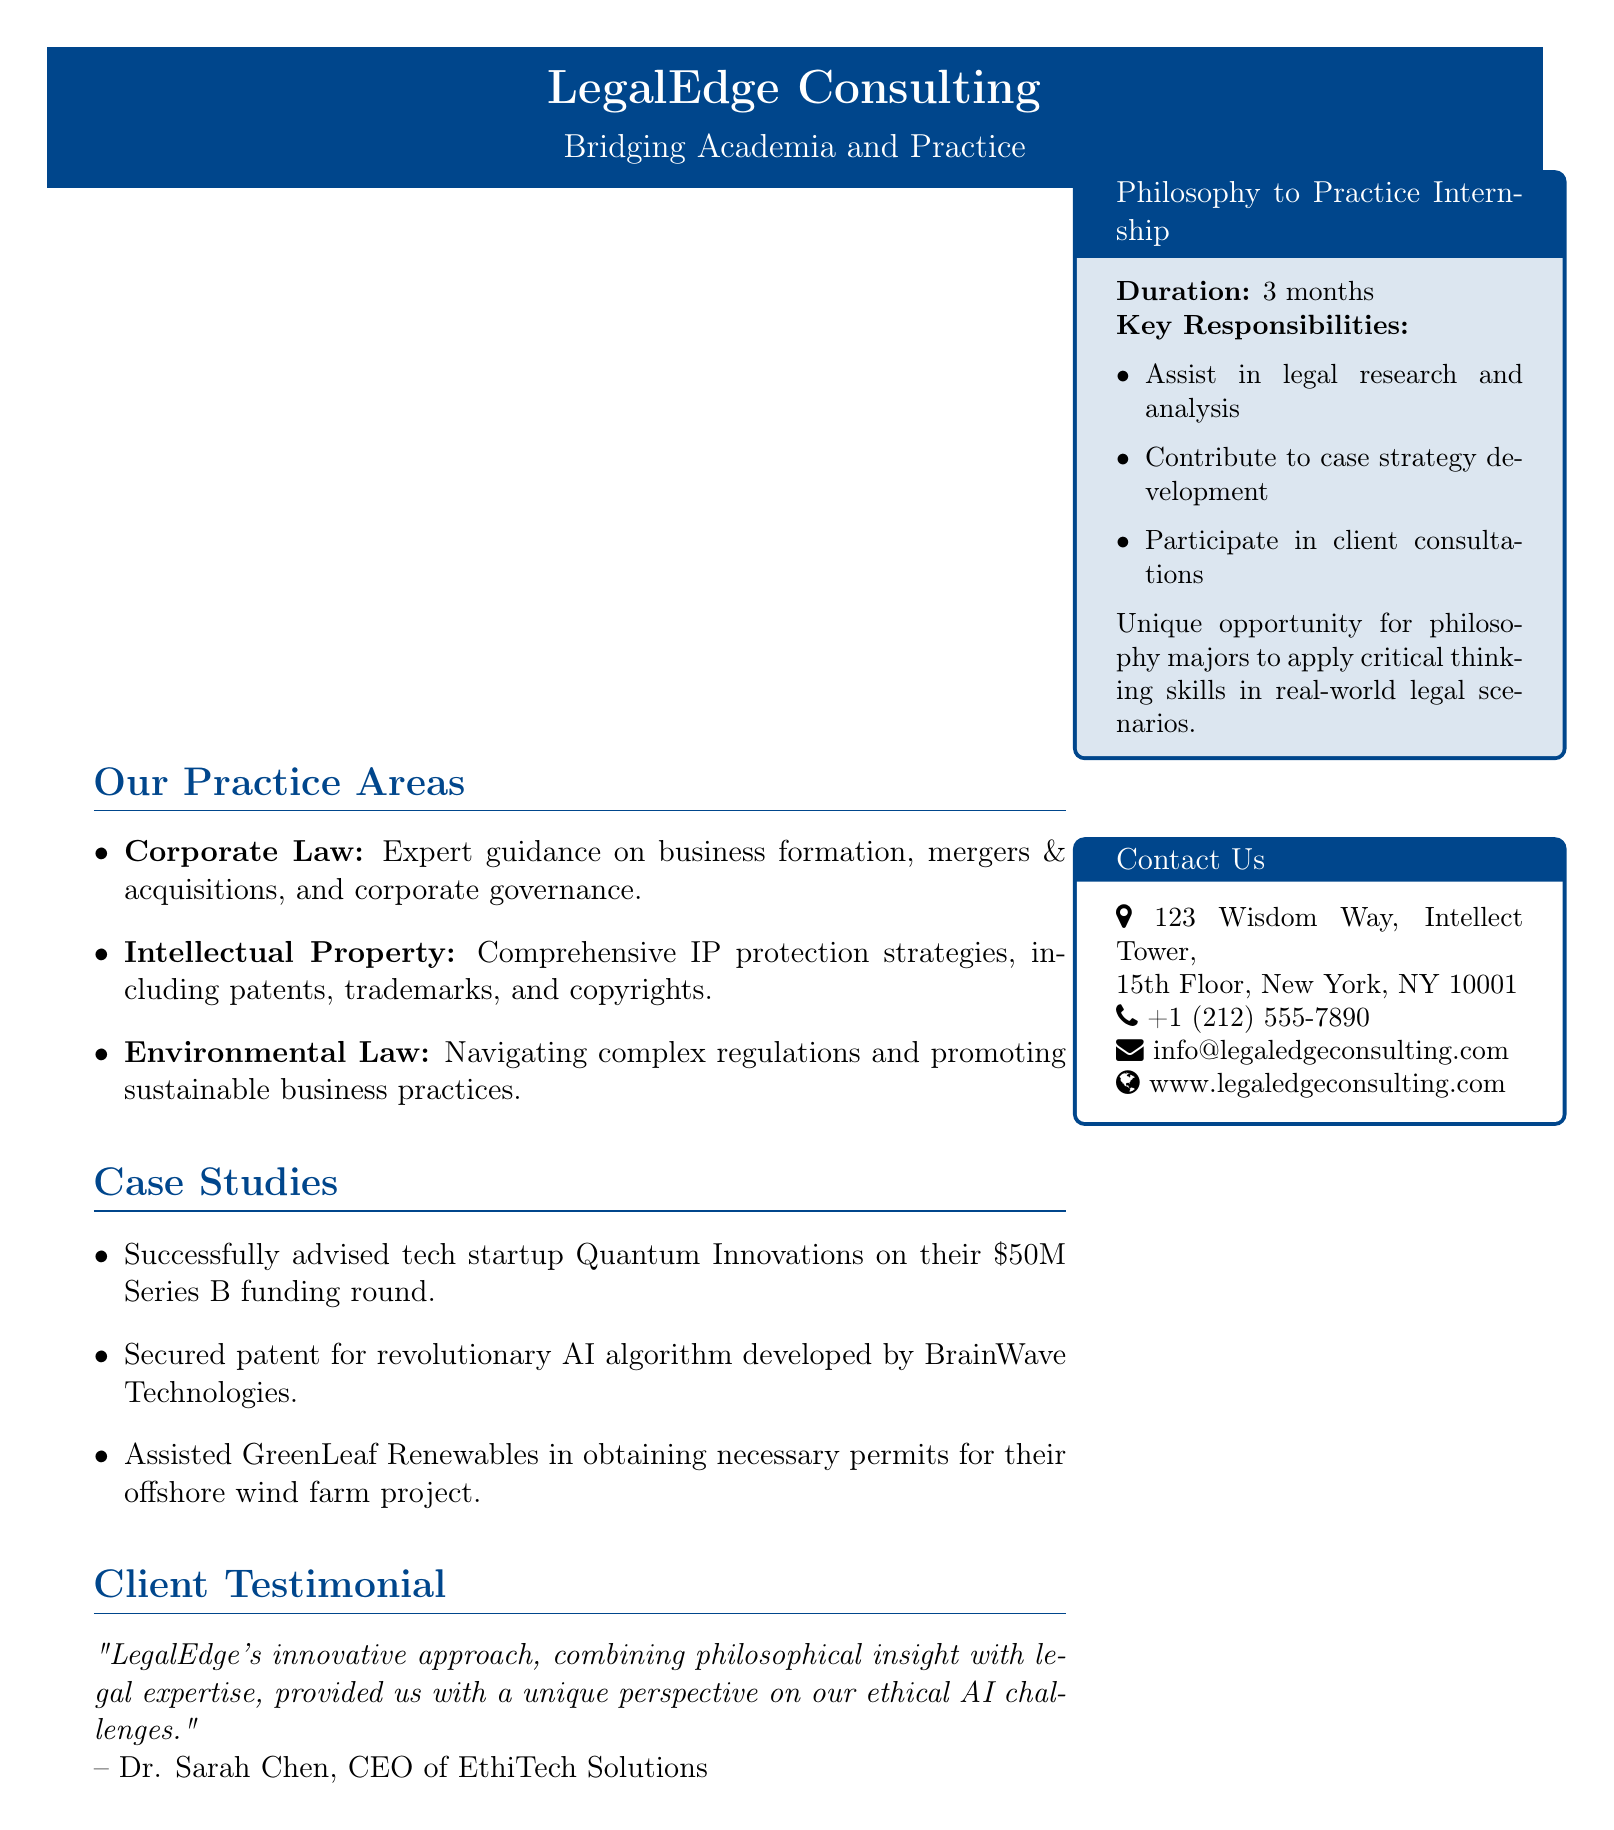What are the main practice areas of the firm? The question asks for a summary of the services offered by the firm, which includes specific areas detailed in the document.
Answer: Corporate Law, Intellectual Property, Environmental Law What is the duration of the Philosophy to Practice Internship? The internship duration is explicitly stated in the document.
Answer: 3 months Who is the CEO of EthiTech Solutions? The question refers to a client testimonial in the document that mentions Dr. Sarah Chen.
Answer: Dr. Sarah Chen What was the funding amount for Quantum Innovations? This information relates to a specific case study highlighted in the document.
Answer: $50M What key responsibility is involved in the internship? The question seeks specific tasks associated with the internship which are listed in the document.
Answer: Assist in legal research and analysis How many case studies are mentioned in the document? This requires counting the instances provided in the case studies section.
Answer: 3 What type of approach does LegalEdge use, according to Dr. Sarah Chen? This question refers to the unique perspective mentioned in the client testimonial.
Answer: Innovative approach What kind of organizations does the firm assist in the Environmental Law practice area? The document states a specific project type reflecting the firm's expertise in this area.
Answer: Offshore wind farm project 